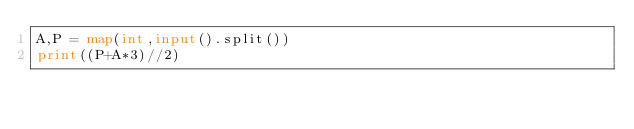<code> <loc_0><loc_0><loc_500><loc_500><_Python_>A,P = map(int,input().split())
print((P+A*3)//2)</code> 